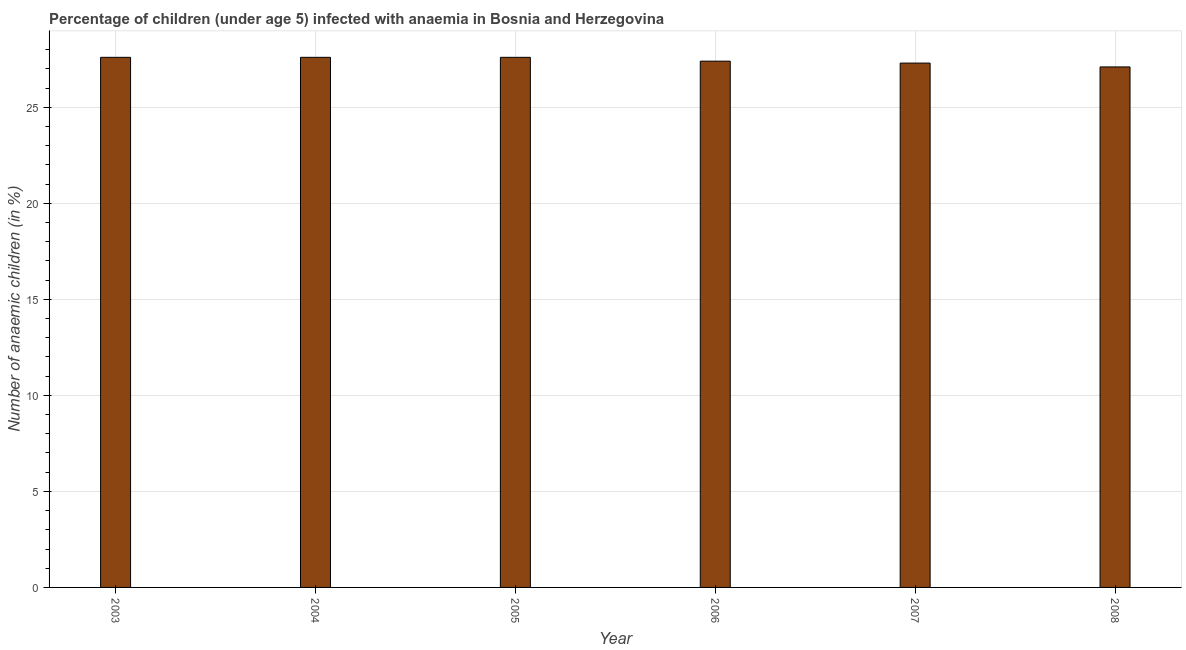Does the graph contain any zero values?
Your answer should be very brief. No. What is the title of the graph?
Keep it short and to the point. Percentage of children (under age 5) infected with anaemia in Bosnia and Herzegovina. What is the label or title of the Y-axis?
Give a very brief answer. Number of anaemic children (in %). What is the number of anaemic children in 2007?
Ensure brevity in your answer.  27.3. Across all years, what is the maximum number of anaemic children?
Your answer should be compact. 27.6. Across all years, what is the minimum number of anaemic children?
Keep it short and to the point. 27.1. In which year was the number of anaemic children maximum?
Offer a terse response. 2003. What is the sum of the number of anaemic children?
Keep it short and to the point. 164.6. What is the difference between the number of anaemic children in 2005 and 2006?
Your answer should be very brief. 0.2. What is the average number of anaemic children per year?
Give a very brief answer. 27.43. What is the median number of anaemic children?
Keep it short and to the point. 27.5. In how many years, is the number of anaemic children greater than 16 %?
Give a very brief answer. 6. Is the number of anaemic children in 2004 less than that in 2006?
Offer a terse response. No. Is the difference between the number of anaemic children in 2004 and 2005 greater than the difference between any two years?
Make the answer very short. No. What is the difference between the highest and the second highest number of anaemic children?
Your answer should be compact. 0. Is the sum of the number of anaemic children in 2005 and 2008 greater than the maximum number of anaemic children across all years?
Your response must be concise. Yes. In how many years, is the number of anaemic children greater than the average number of anaemic children taken over all years?
Offer a terse response. 3. Are all the bars in the graph horizontal?
Offer a very short reply. No. How many years are there in the graph?
Your answer should be compact. 6. What is the difference between two consecutive major ticks on the Y-axis?
Your answer should be compact. 5. Are the values on the major ticks of Y-axis written in scientific E-notation?
Keep it short and to the point. No. What is the Number of anaemic children (in %) of 2003?
Offer a very short reply. 27.6. What is the Number of anaemic children (in %) of 2004?
Provide a short and direct response. 27.6. What is the Number of anaemic children (in %) of 2005?
Ensure brevity in your answer.  27.6. What is the Number of anaemic children (in %) of 2006?
Offer a very short reply. 27.4. What is the Number of anaemic children (in %) of 2007?
Give a very brief answer. 27.3. What is the Number of anaemic children (in %) of 2008?
Make the answer very short. 27.1. What is the difference between the Number of anaemic children (in %) in 2003 and 2005?
Your answer should be very brief. 0. What is the difference between the Number of anaemic children (in %) in 2003 and 2006?
Make the answer very short. 0.2. What is the difference between the Number of anaemic children (in %) in 2003 and 2007?
Make the answer very short. 0.3. What is the difference between the Number of anaemic children (in %) in 2005 and 2006?
Your response must be concise. 0.2. What is the difference between the Number of anaemic children (in %) in 2005 and 2007?
Offer a terse response. 0.3. What is the difference between the Number of anaemic children (in %) in 2005 and 2008?
Provide a succinct answer. 0.5. What is the ratio of the Number of anaemic children (in %) in 2003 to that in 2005?
Your answer should be compact. 1. What is the ratio of the Number of anaemic children (in %) in 2003 to that in 2006?
Offer a terse response. 1.01. What is the ratio of the Number of anaemic children (in %) in 2003 to that in 2007?
Provide a succinct answer. 1.01. What is the ratio of the Number of anaemic children (in %) in 2003 to that in 2008?
Your response must be concise. 1.02. What is the ratio of the Number of anaemic children (in %) in 2004 to that in 2005?
Provide a short and direct response. 1. What is the ratio of the Number of anaemic children (in %) in 2004 to that in 2008?
Provide a succinct answer. 1.02. What is the ratio of the Number of anaemic children (in %) in 2005 to that in 2006?
Provide a succinct answer. 1.01. What is the ratio of the Number of anaemic children (in %) in 2006 to that in 2008?
Offer a terse response. 1.01. What is the ratio of the Number of anaemic children (in %) in 2007 to that in 2008?
Keep it short and to the point. 1.01. 